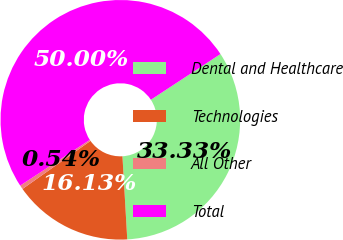Convert chart to OTSL. <chart><loc_0><loc_0><loc_500><loc_500><pie_chart><fcel>Dental and Healthcare<fcel>Technologies<fcel>All Other<fcel>Total<nl><fcel>33.33%<fcel>16.13%<fcel>0.54%<fcel>50.0%<nl></chart> 